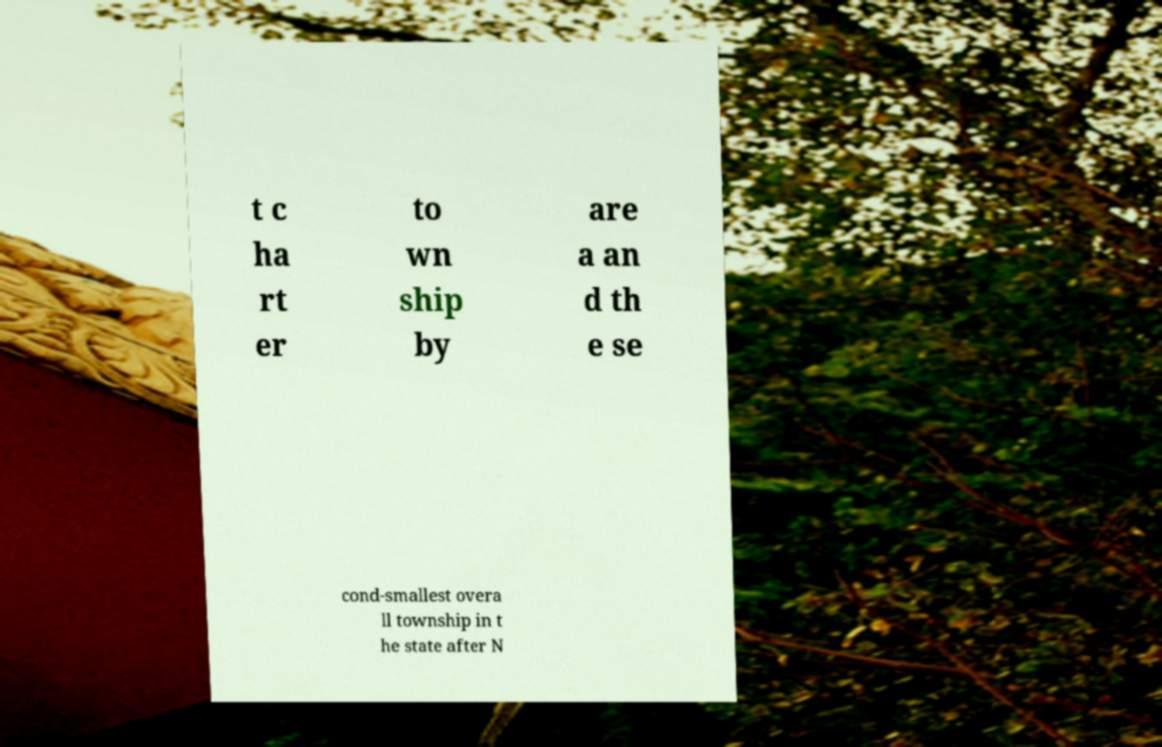Could you assist in decoding the text presented in this image and type it out clearly? t c ha rt er to wn ship by are a an d th e se cond-smallest overa ll township in t he state after N 